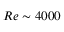<formula> <loc_0><loc_0><loc_500><loc_500>R e \sim 4 0 0 0</formula> 